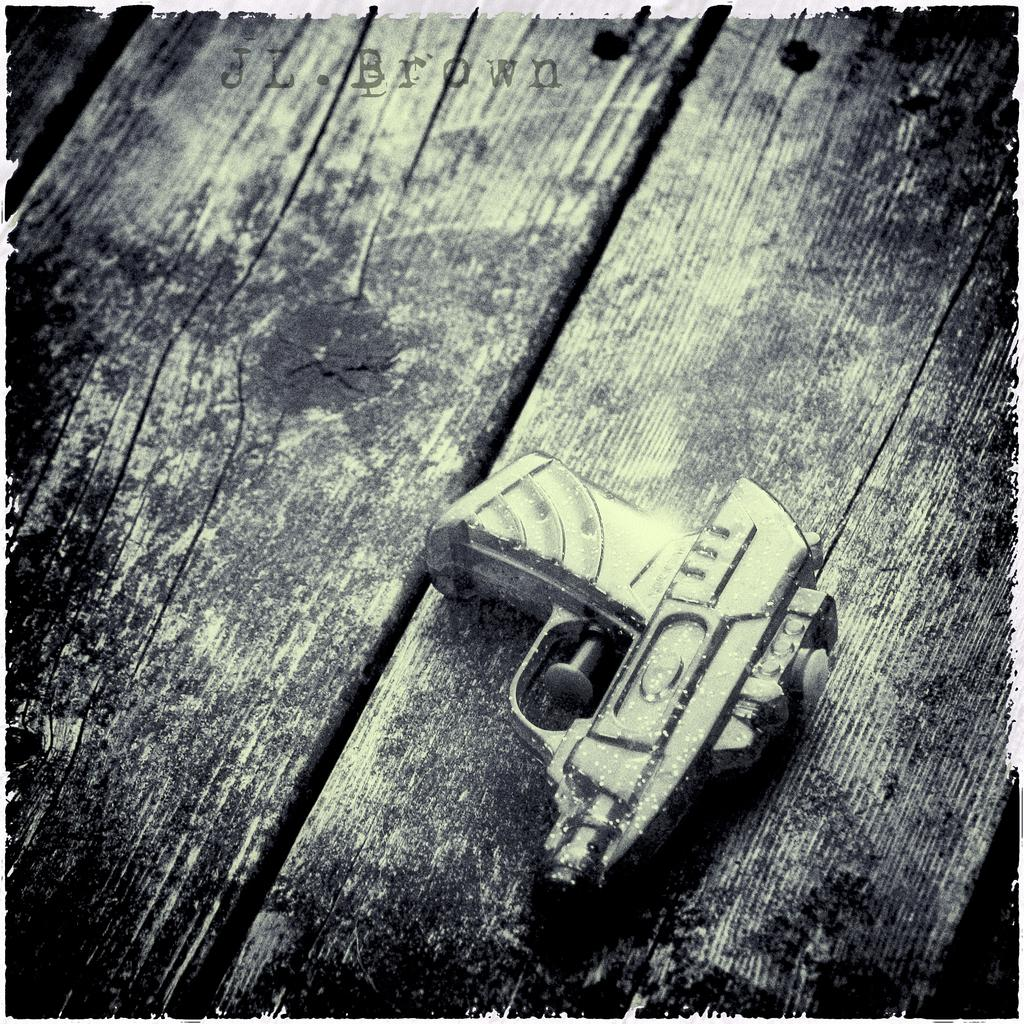What object is the main focus of the image? There is a gun in the image. Where is the gun placed? The gun is on a wooden surface. What can be seen at the top of the image? There is some text at the top of the image. What color is the jail in the image? There is no jail present in the image. 